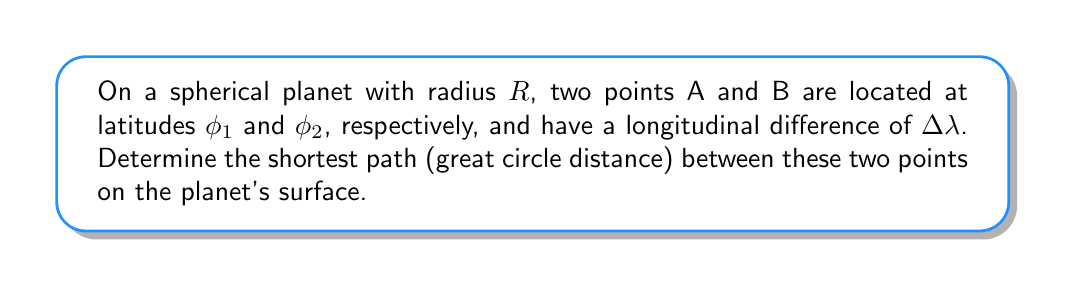Help me with this question. To solve this problem, we'll use the spherical law of cosines. The steps are as follows:

1. The spherical law of cosines for the central angle $\theta$ between two points on a sphere is:

   $$\cos(\theta) = \sin(\phi_1)\sin(\phi_2) + \cos(\phi_1)\cos(\phi_2)\cos(\Delta \lambda)$$

2. Once we have $\theta$, we can calculate the great circle distance $d$ using:

   $$d = R\theta$$

   where $\theta$ is in radians.

3. To convert $\theta$ from the cosine form to radians, we use the arccos function:

   $$\theta = \arccos(\sin(\phi_1)\sin(\phi_2) + \cos(\phi_1)\cos(\phi_2)\cos(\Delta \lambda))$$

4. Substituting this into the distance formula:

   $$d = R \cdot \arccos(\sin(\phi_1)\sin(\phi_2) + \cos(\phi_1)\cos(\phi_2)\cos(\Delta \lambda))$$

This formula gives us the shortest path between two points on a spherical surface, which is the great circle distance.

[asy]
import geometry;

size(200);
real R = 5;
real phi1 = pi/4;
real phi2 = pi/3;
real dlambda = pi/2;

triple sph2cart(real R, real phi, real lambda) {
  return (R*cos(phi)*cos(lambda), R*cos(phi)*sin(lambda), R*sin(phi));
}

triple A = sph2cart(R, phi1, 0);
triple B = sph2cart(R, phi2, dlambda);
triple O = (0,0,0);

draw(circle(O, R), blue);
draw(O--A, dashed);
draw(O--B, dashed);
draw(arc(O, A, B), red);

dot("A", A, N);
dot("B", B, E);
dot("O", O, SW);

label("Great circle path", (2,2), red);
[/asy]
Answer: $d = R \cdot \arccos(\sin(\phi_1)\sin(\phi_2) + \cos(\phi_1)\cos(\phi_2)\cos(\Delta \lambda))$ 